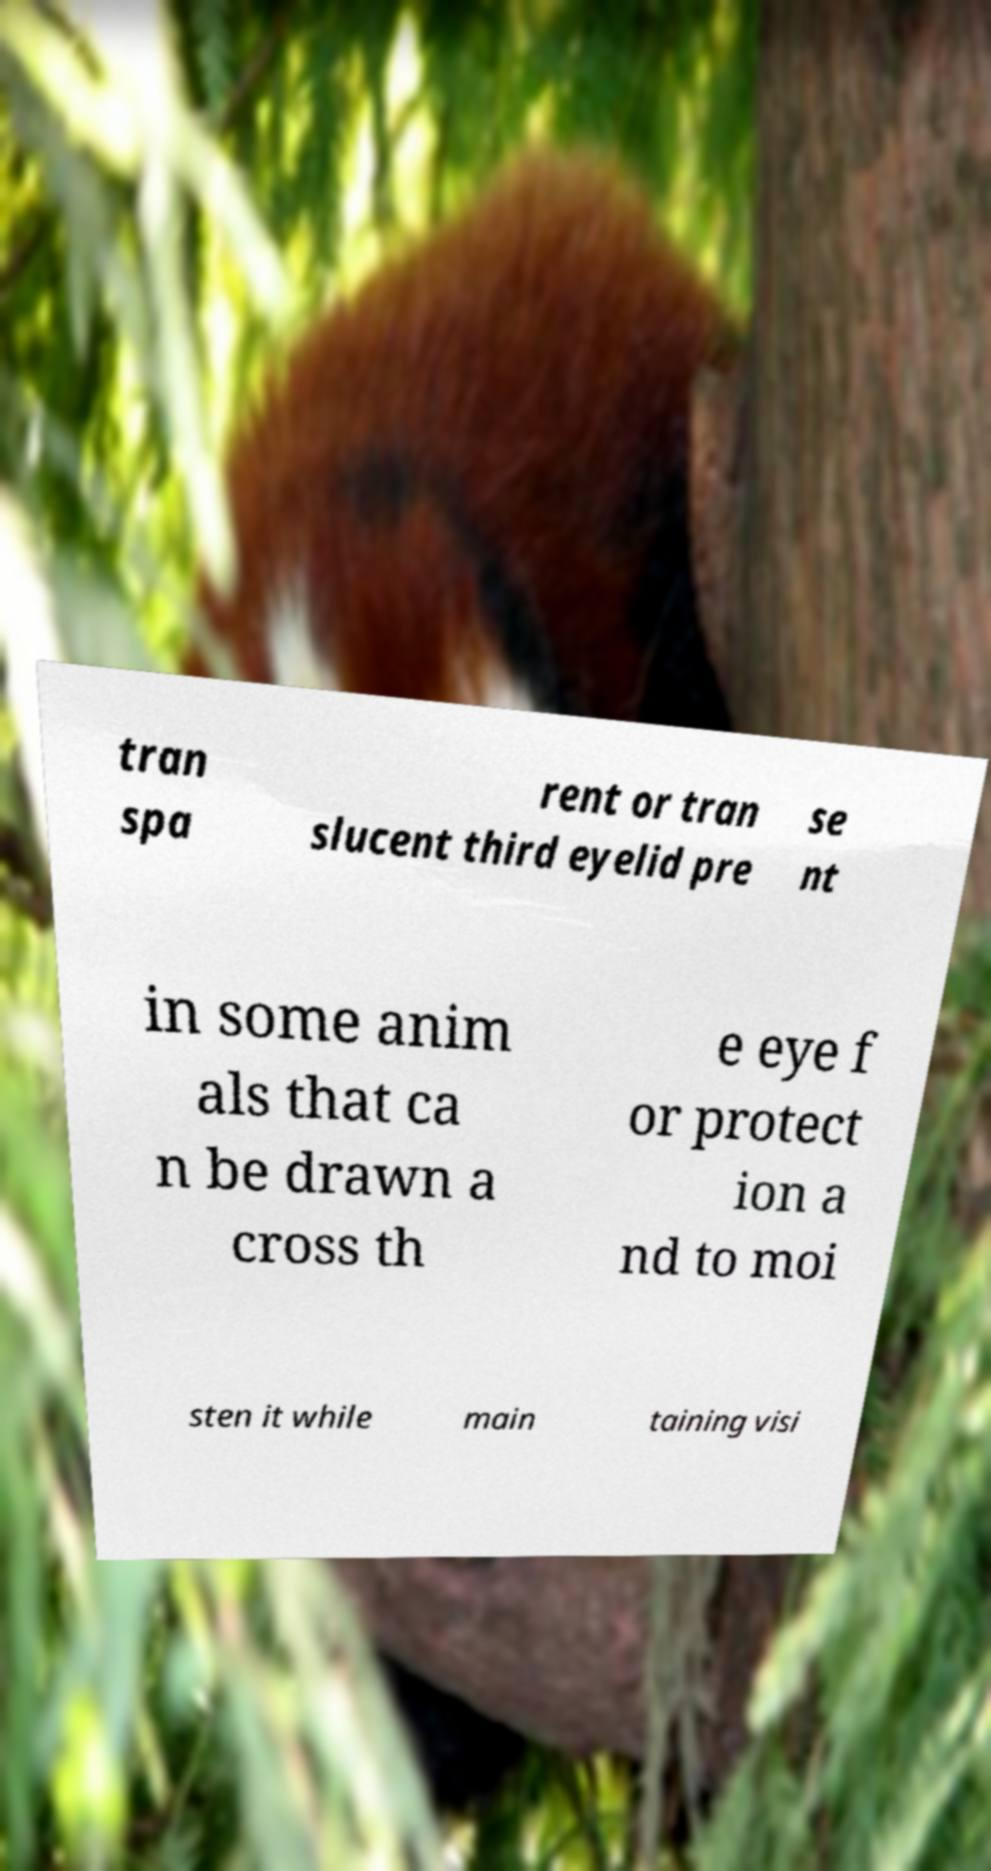Could you assist in decoding the text presented in this image and type it out clearly? tran spa rent or tran slucent third eyelid pre se nt in some anim als that ca n be drawn a cross th e eye f or protect ion a nd to moi sten it while main taining visi 